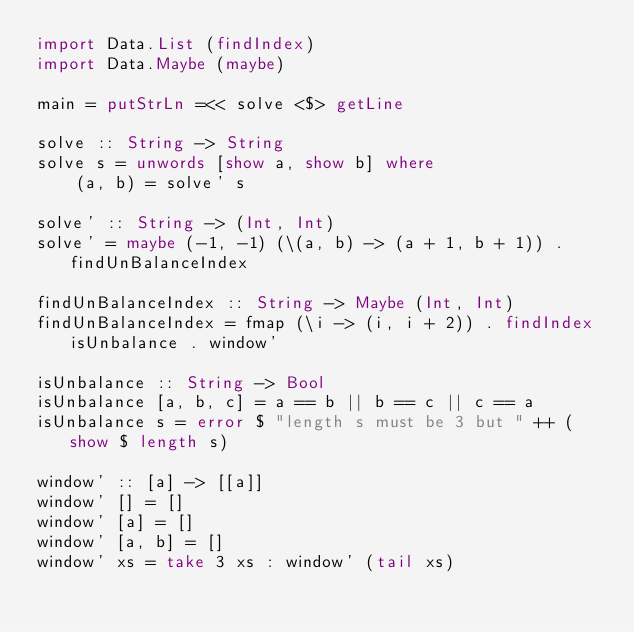Convert code to text. <code><loc_0><loc_0><loc_500><loc_500><_Haskell_>import Data.List (findIndex)
import Data.Maybe (maybe)

main = putStrLn =<< solve <$> getLine

solve :: String -> String
solve s = unwords [show a, show b] where
    (a, b) = solve' s

solve' :: String -> (Int, Int)
solve' = maybe (-1, -1) (\(a, b) -> (a + 1, b + 1)) . findUnBalanceIndex

findUnBalanceIndex :: String -> Maybe (Int, Int)
findUnBalanceIndex = fmap (\i -> (i, i + 2)) . findIndex isUnbalance . window'

isUnbalance :: String -> Bool
isUnbalance [a, b, c] = a == b || b == c || c == a
isUnbalance s = error $ "length s must be 3 but " ++ (show $ length s)

window' :: [a] -> [[a]]
window' [] = []
window' [a] = []
window' [a, b] = []
window' xs = take 3 xs : window' (tail xs)
</code> 